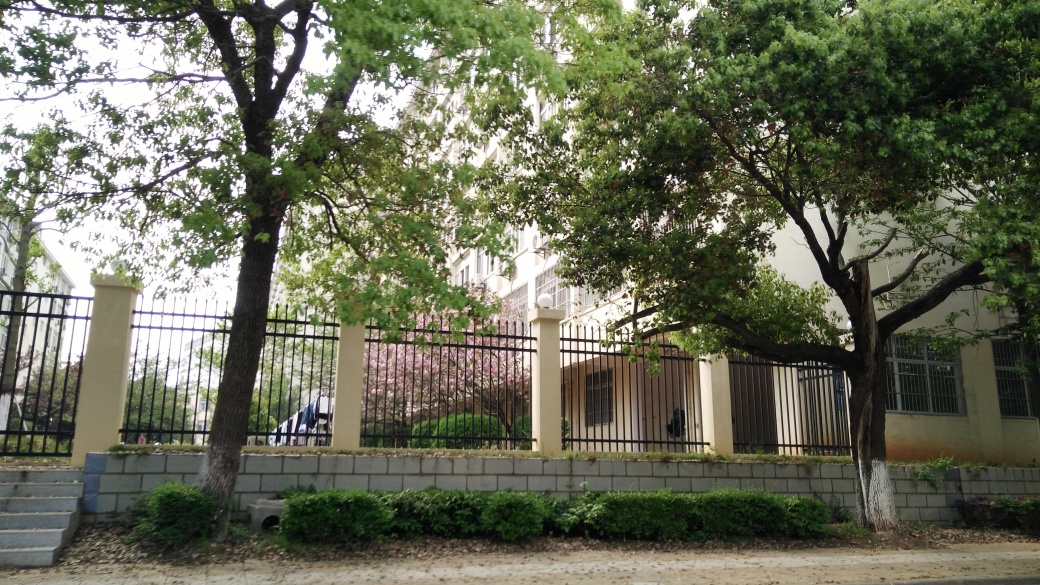What details in the image might tell us about the season or time of year? The leaves on the trees appear to be green and full, suggesting it is either spring or summer. The lighting is soft, which might indicate it's either early morning or late afternoon. Additionally, there is no sign of fallen leaves or snow, which would suggest it's not autumn or winter. Could the climate of the location be inferred from the plants or the building's architecture? The presence of robust, green foliage suggests a climate that supports vigorous plant growth, likely indicating a temperate or subtropical climate. The architecture, with its large windows and light-colored facade, speaks to a design that is compatible with regions that might experience a variety of weather conditions, thus reinforcing the assumption of a temperate climate. 